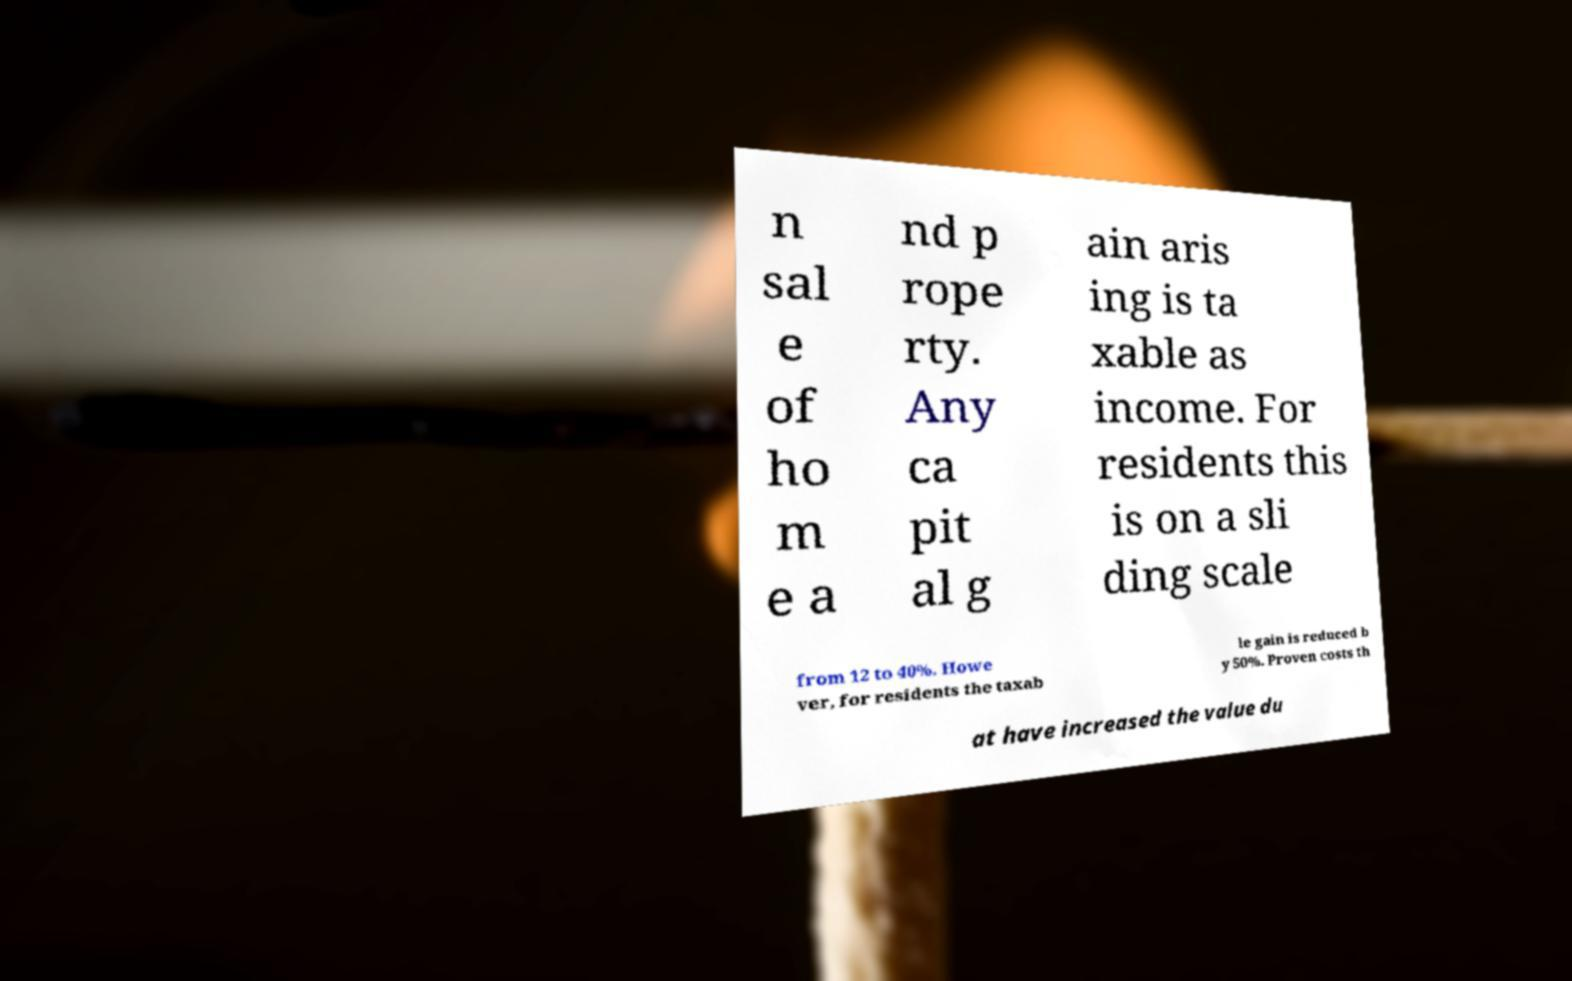What messages or text are displayed in this image? I need them in a readable, typed format. n sal e of ho m e a nd p rope rty. Any ca pit al g ain aris ing is ta xable as income. For residents this is on a sli ding scale from 12 to 40%. Howe ver, for residents the taxab le gain is reduced b y 50%. Proven costs th at have increased the value du 